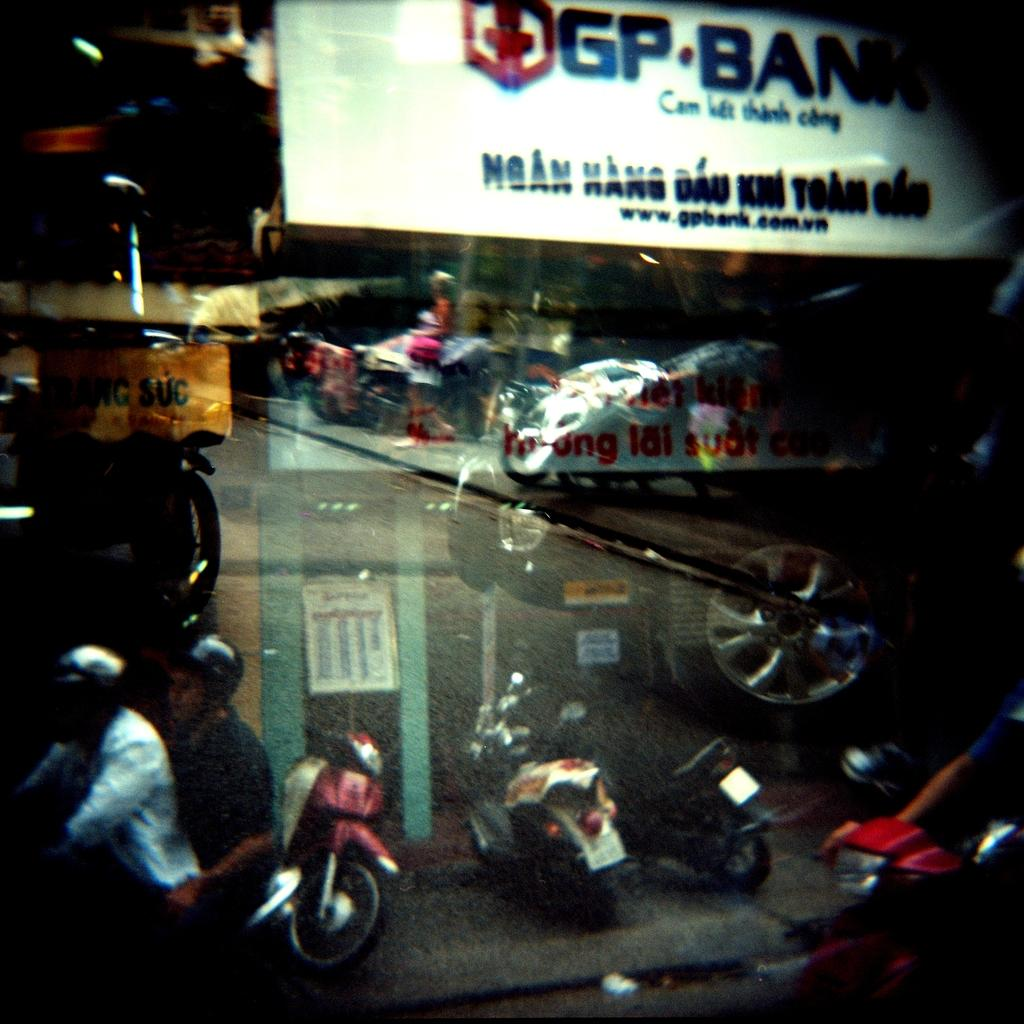What object is present in the image that can hold a liquid? There is a glass in the image. What can be seen in the reflection of the glass? The glass has a reflection of vehicles and persons. What is written or displayed at the top of the image? There is a banner with text at the top of the image. What type of cheese is being used to fix the lumber in the image? There is no cheese or lumber present in the image. What tool is being used to tighten the wrench in the image? There is no wrench or tool present in the image. 